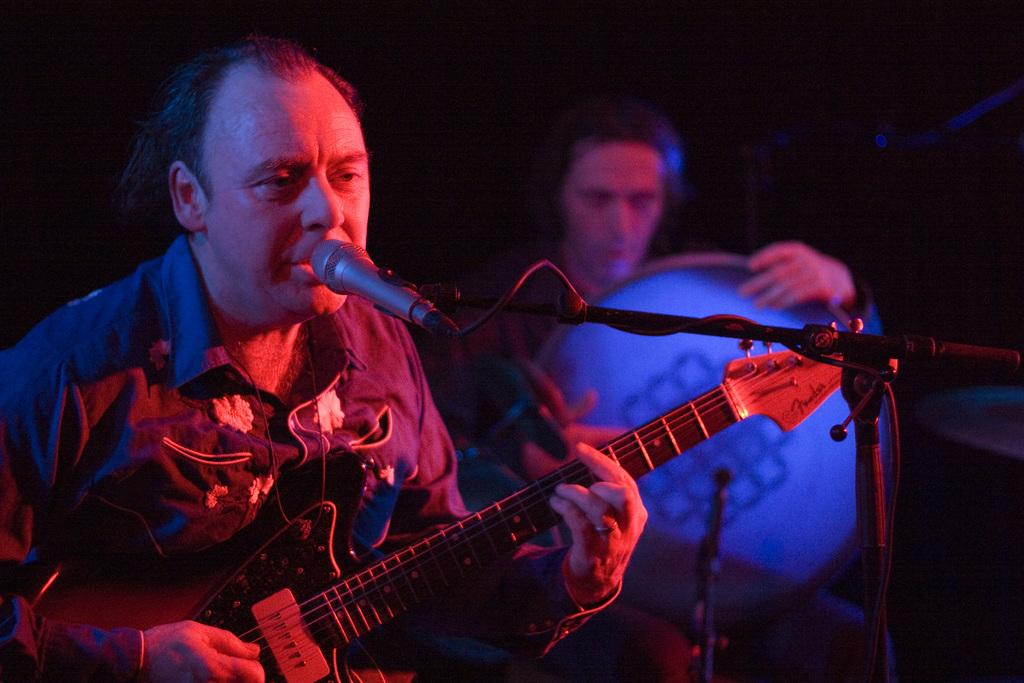What is the main object in the middle of the image? There is a microphone in the middle of the image. What are the two men in the image doing? One man is playing a guitar on the bottom left side of the image, and another man is playing a musical instrument on the bottom right side of the image. Where is the throne located in the image? There is no throne present in the image. What route are the musicians taking to reach their performance location? The image does not show any movement or route, as it is a still image of the musicians playing their instruments. 